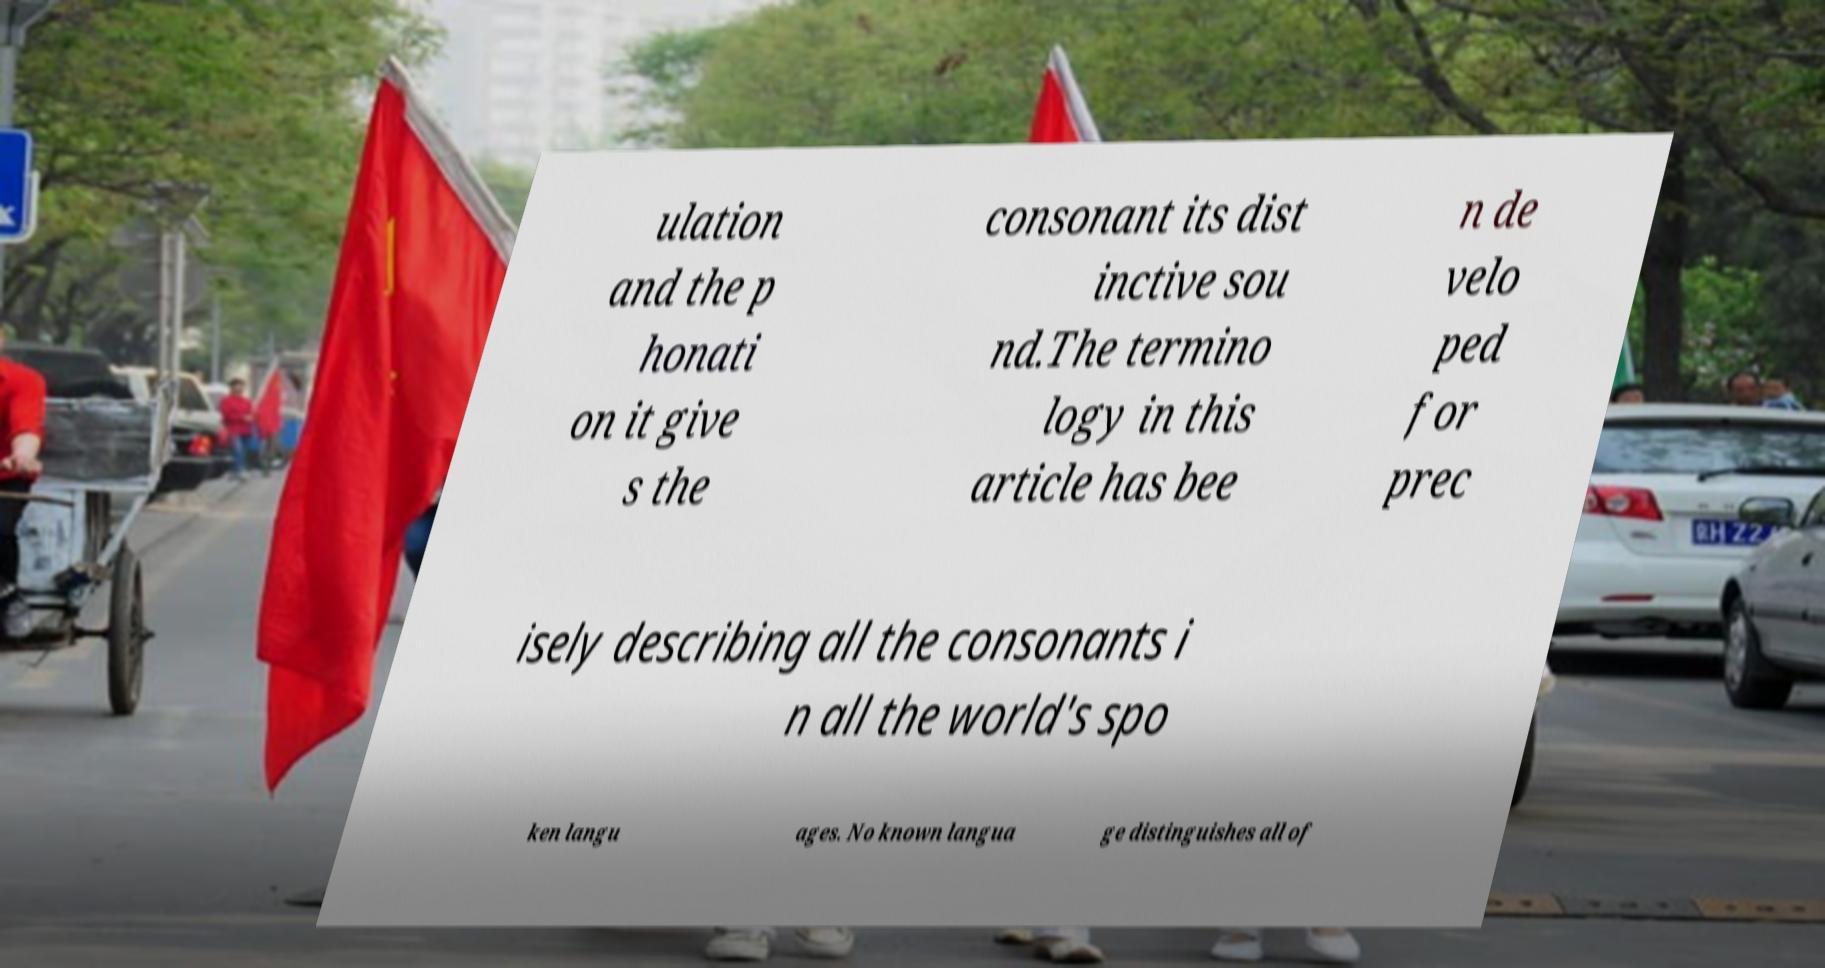Could you assist in decoding the text presented in this image and type it out clearly? ulation and the p honati on it give s the consonant its dist inctive sou nd.The termino logy in this article has bee n de velo ped for prec isely describing all the consonants i n all the world's spo ken langu ages. No known langua ge distinguishes all of 